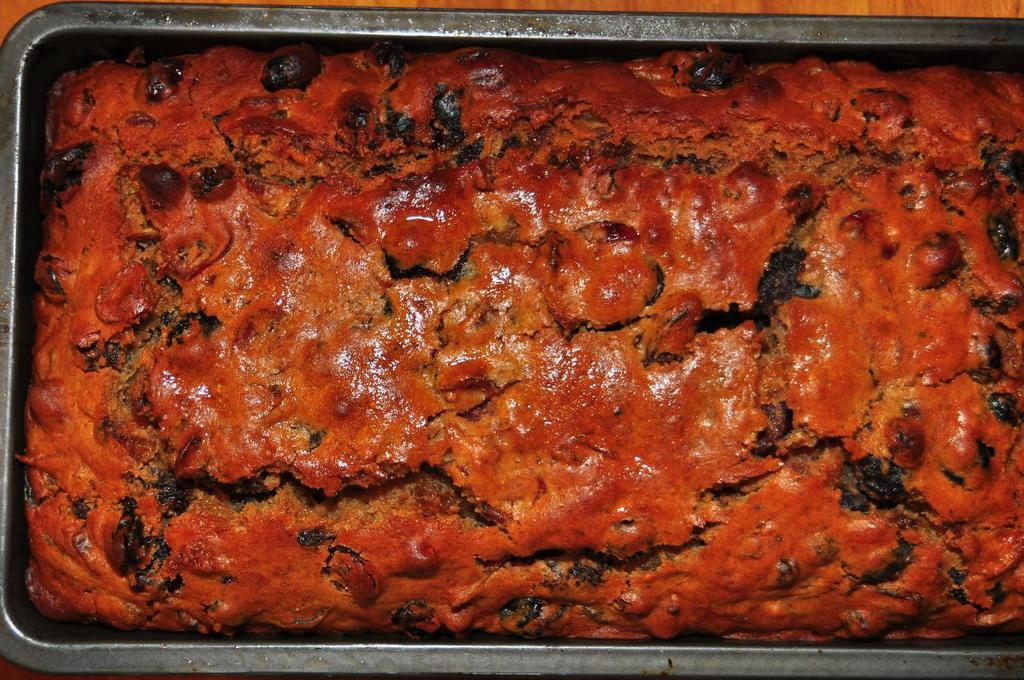What type of food is visible in the image? The food in the image is red in color. How is the red food contained or presented? The food is placed in a box. What is the color of the table on which the box is placed? The table is brown. Is there a chair made of butter in the image? No, there is no chair made of butter in the image. 